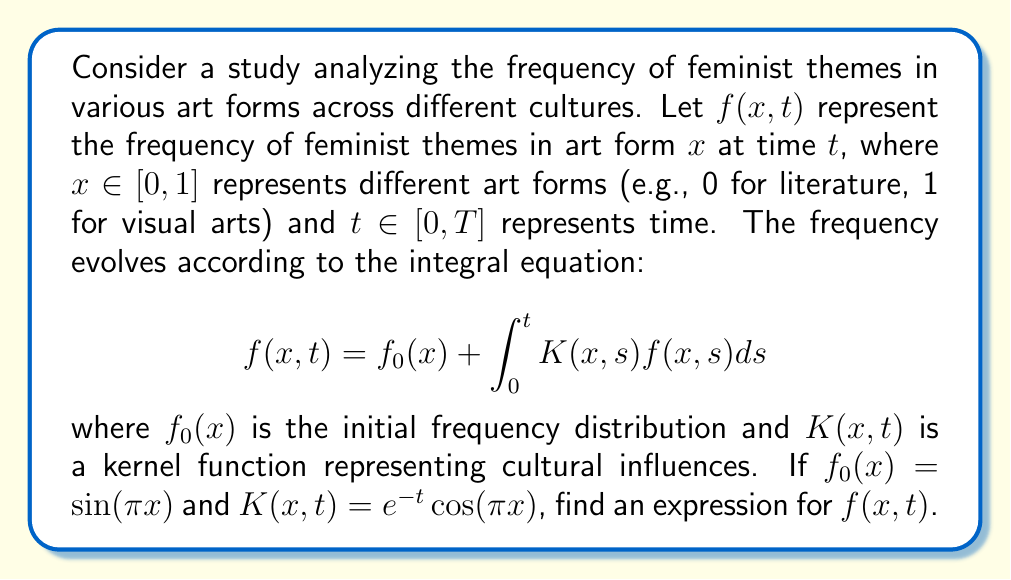Teach me how to tackle this problem. To solve this integral equation, we'll use the method of successive approximations:

1) Start with the initial approximation $f_0(x) = \sin(\pi x)$

2) Substitute this into the right-hand side of the equation:
   $$f_1(x,t) = \sin(\pi x) + \int_0^t e^{-s}\cos(\pi x)\sin(\pi x) ds$$

3) Evaluate the integral:
   $$f_1(x,t) = \sin(\pi x) + \cos(\pi x)\sin(\pi x) \int_0^t e^{-s} ds$$
   $$f_1(x,t) = \sin(\pi x) + \cos(\pi x)\sin(\pi x) [- e^{-s}]_0^t$$
   $$f_1(x,t) = \sin(\pi x) + \cos(\pi x)\sin(\pi x) (1 - e^{-t})$$

4) For the next approximation, we substitute $f_1(x,t)$ back into the equation:
   $$f_2(x,t) = \sin(\pi x) + \int_0^t e^{-s}\cos(\pi x)[\sin(\pi x) + \cos(\pi x)\sin(\pi x) (1 - e^{-s})] ds$$

5) Evaluate this integral:
   $$f_2(x,t) = \sin(\pi x) + \cos(\pi x)\sin(\pi x) (1 - e^{-t}) + \frac{1}{2}\cos^2(\pi x)\sin(\pi x) (t - 1 + e^{-t})$$

6) Continuing this process, we can see a pattern emerging. The general solution can be written as:
   $$f(x,t) = \sin(\pi x) \sum_{n=0}^{\infty} \frac{[\cos(\pi x)(1-e^{-t})]^n}{n!}$$

7) This infinite series is the Taylor expansion of $e^{\cos(\pi x)(1-e^{-t})}$

Therefore, the final solution is:
$$f(x,t) = \sin(\pi x) e^{\cos(\pi x)(1-e^{-t})}$$
Answer: $f(x,t) = \sin(\pi x) e^{\cos(\pi x)(1-e^{-t})}$ 